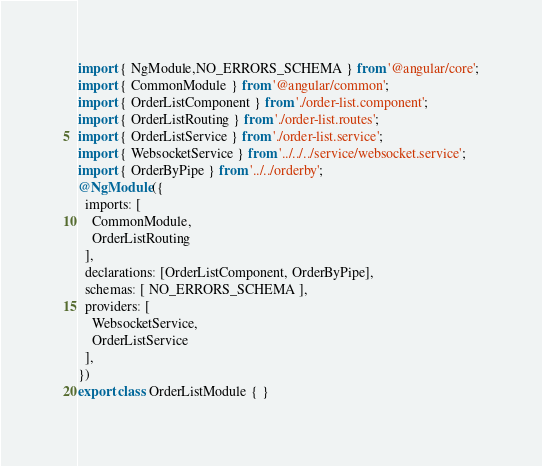Convert code to text. <code><loc_0><loc_0><loc_500><loc_500><_TypeScript_>import { NgModule,NO_ERRORS_SCHEMA } from '@angular/core';
import { CommonModule } from '@angular/common';
import { OrderListComponent } from './order-list.component';
import { OrderListRouting } from './order-list.routes';
import { OrderListService } from './order-list.service';
import { WebsocketService } from '../../../service/websocket.service';
import { OrderByPipe } from '../../orderby';
@NgModule({
  imports: [
    CommonModule,
    OrderListRouting
  ],
  declarations: [OrderListComponent, OrderByPipe],
  schemas: [ NO_ERRORS_SCHEMA ],
  providers: [
    WebsocketService,
    OrderListService
  ],
})
export class OrderListModule { }
</code> 